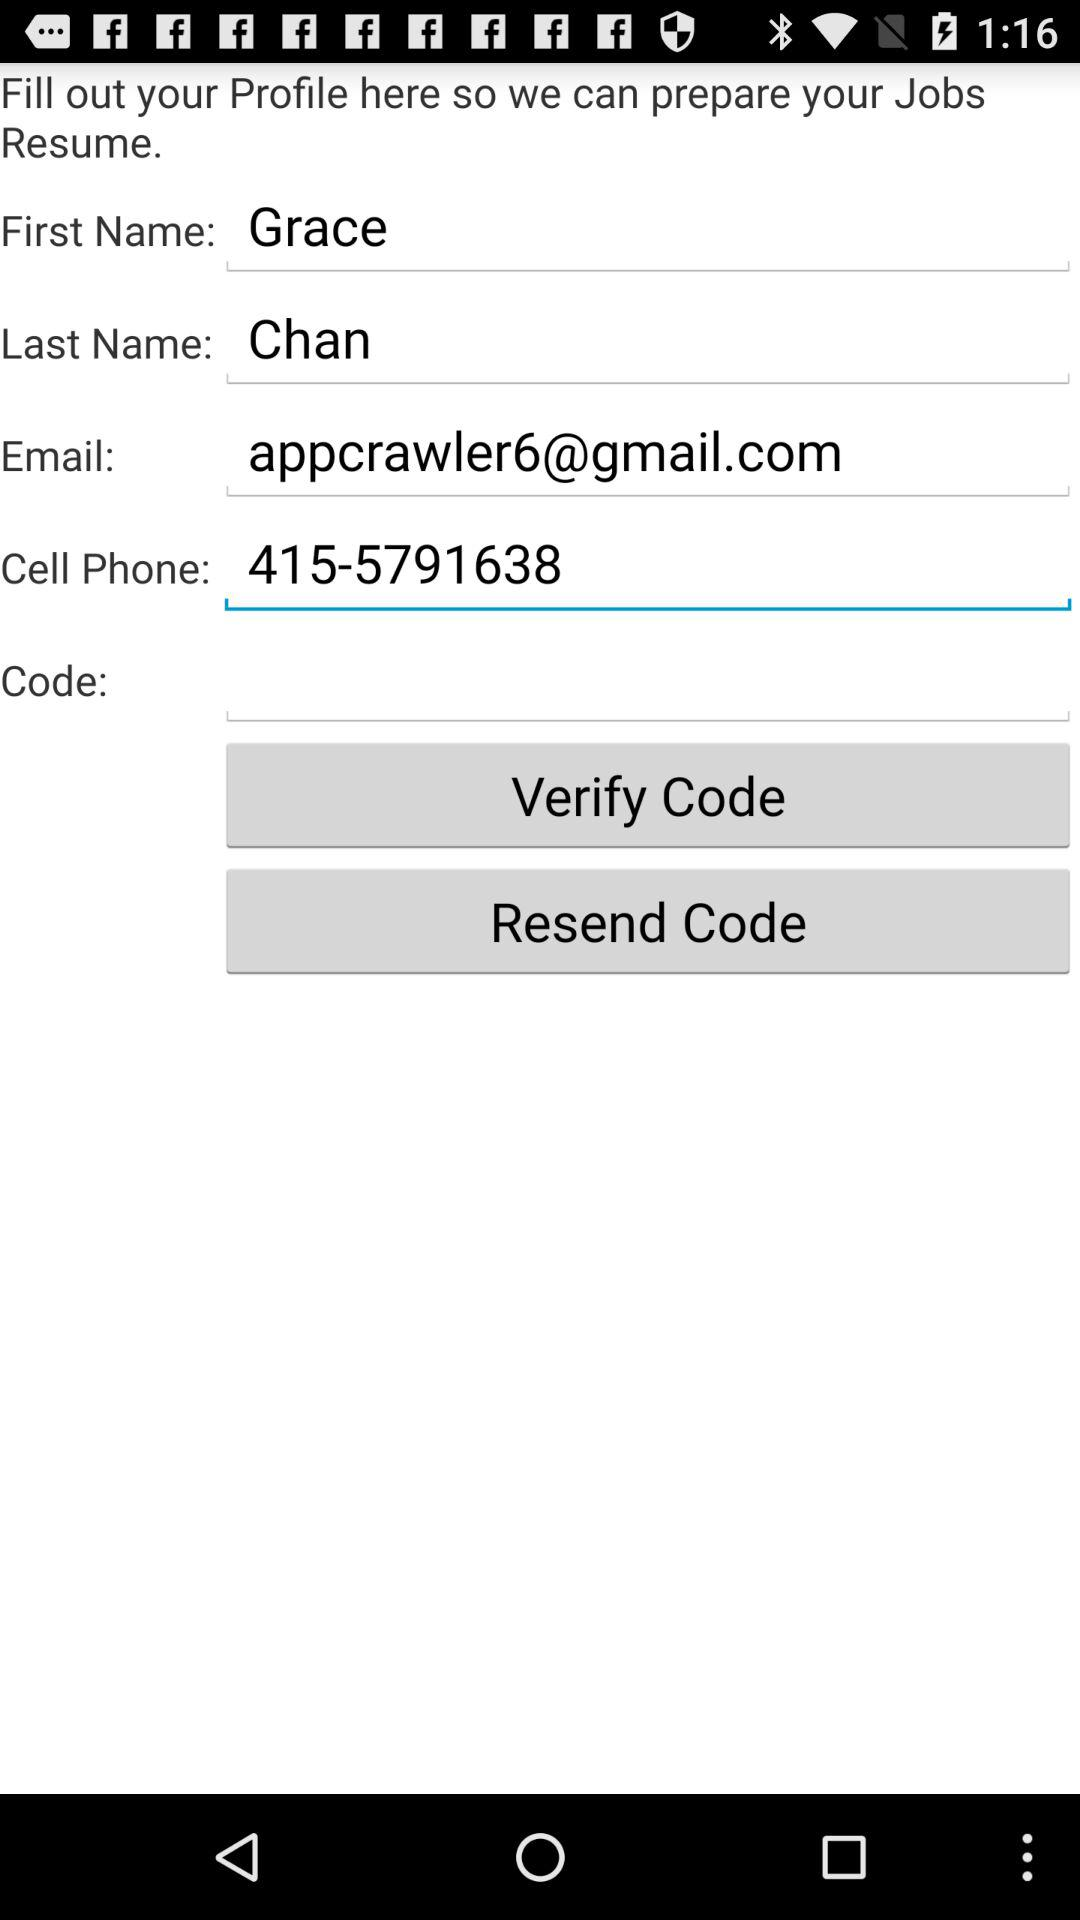What's the Google mail address? The Google mail address is appcrawler6@gmail.com. 